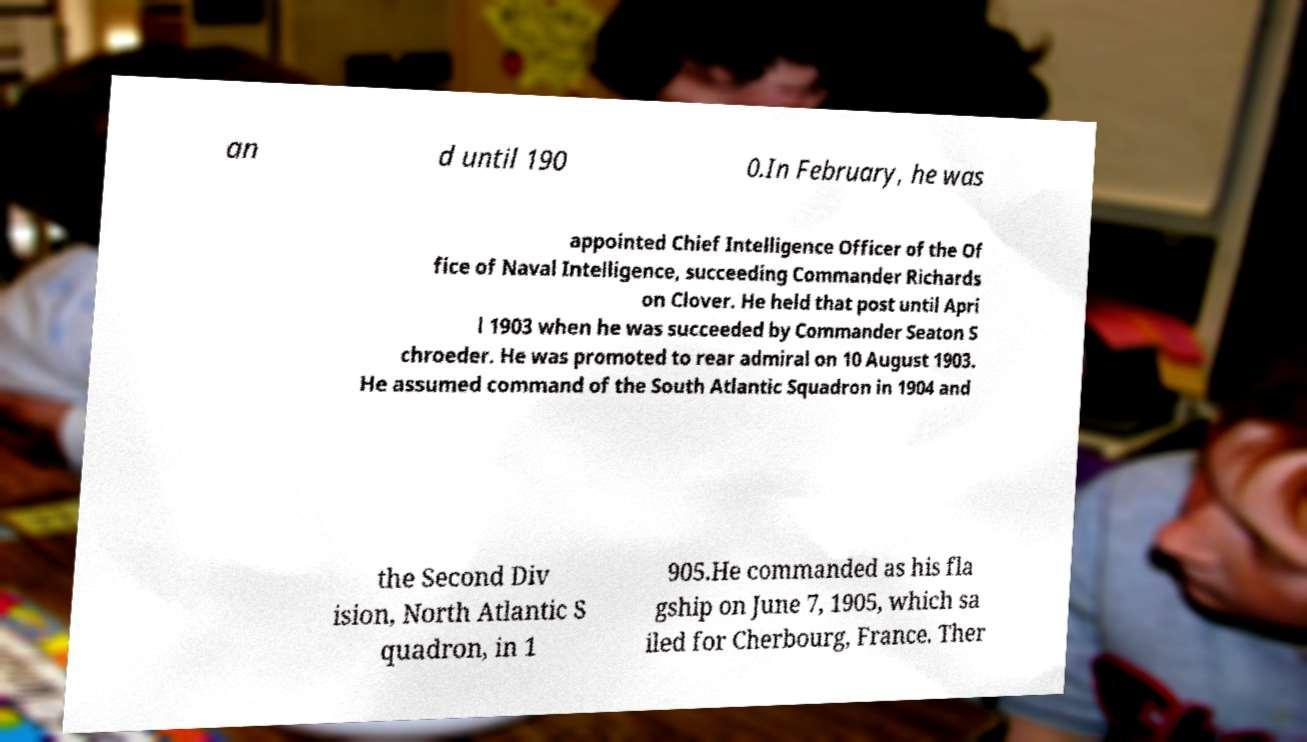Please identify and transcribe the text found in this image. an d until 190 0.In February, he was appointed Chief Intelligence Officer of the Of fice of Naval Intelligence, succeeding Commander Richards on Clover. He held that post until Apri l 1903 when he was succeeded by Commander Seaton S chroeder. He was promoted to rear admiral on 10 August 1903. He assumed command of the South Atlantic Squadron in 1904 and the Second Div ision, North Atlantic S quadron, in 1 905.He commanded as his fla gship on June 7, 1905, which sa iled for Cherbourg, France. Ther 